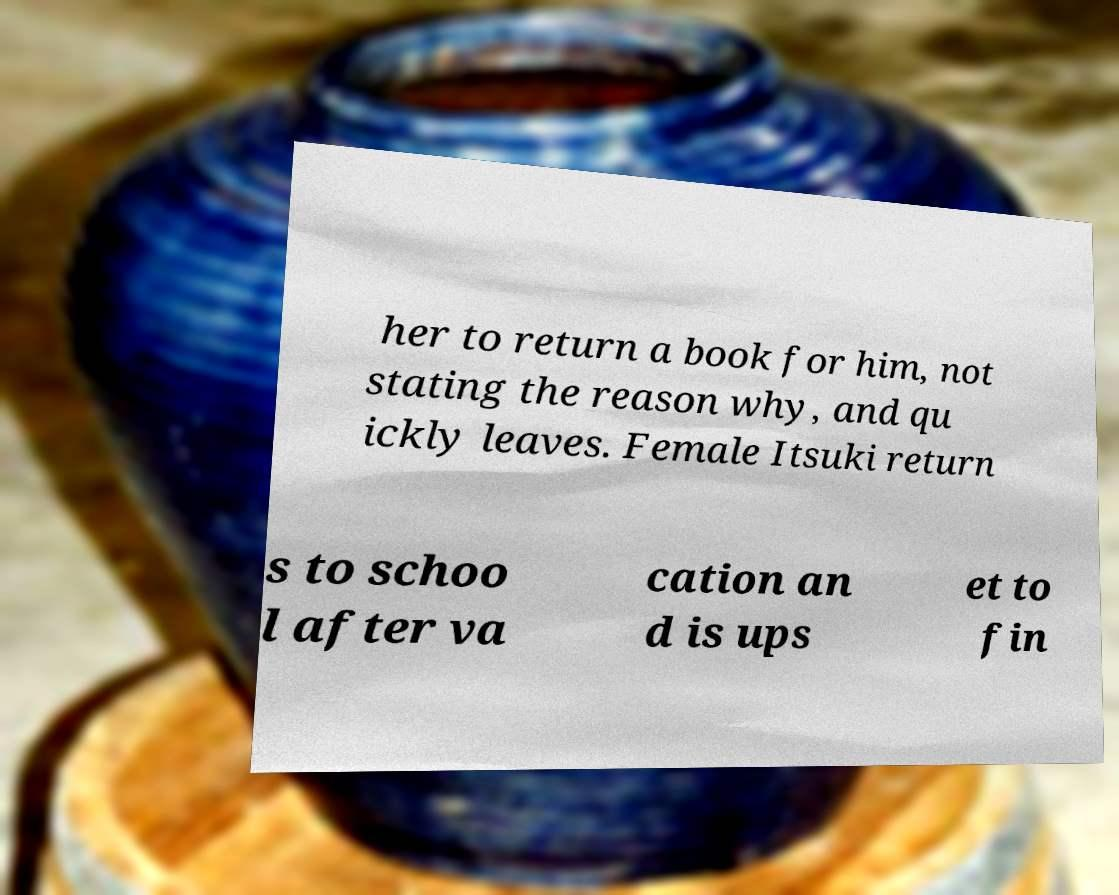Please identify and transcribe the text found in this image. her to return a book for him, not stating the reason why, and qu ickly leaves. Female Itsuki return s to schoo l after va cation an d is ups et to fin 